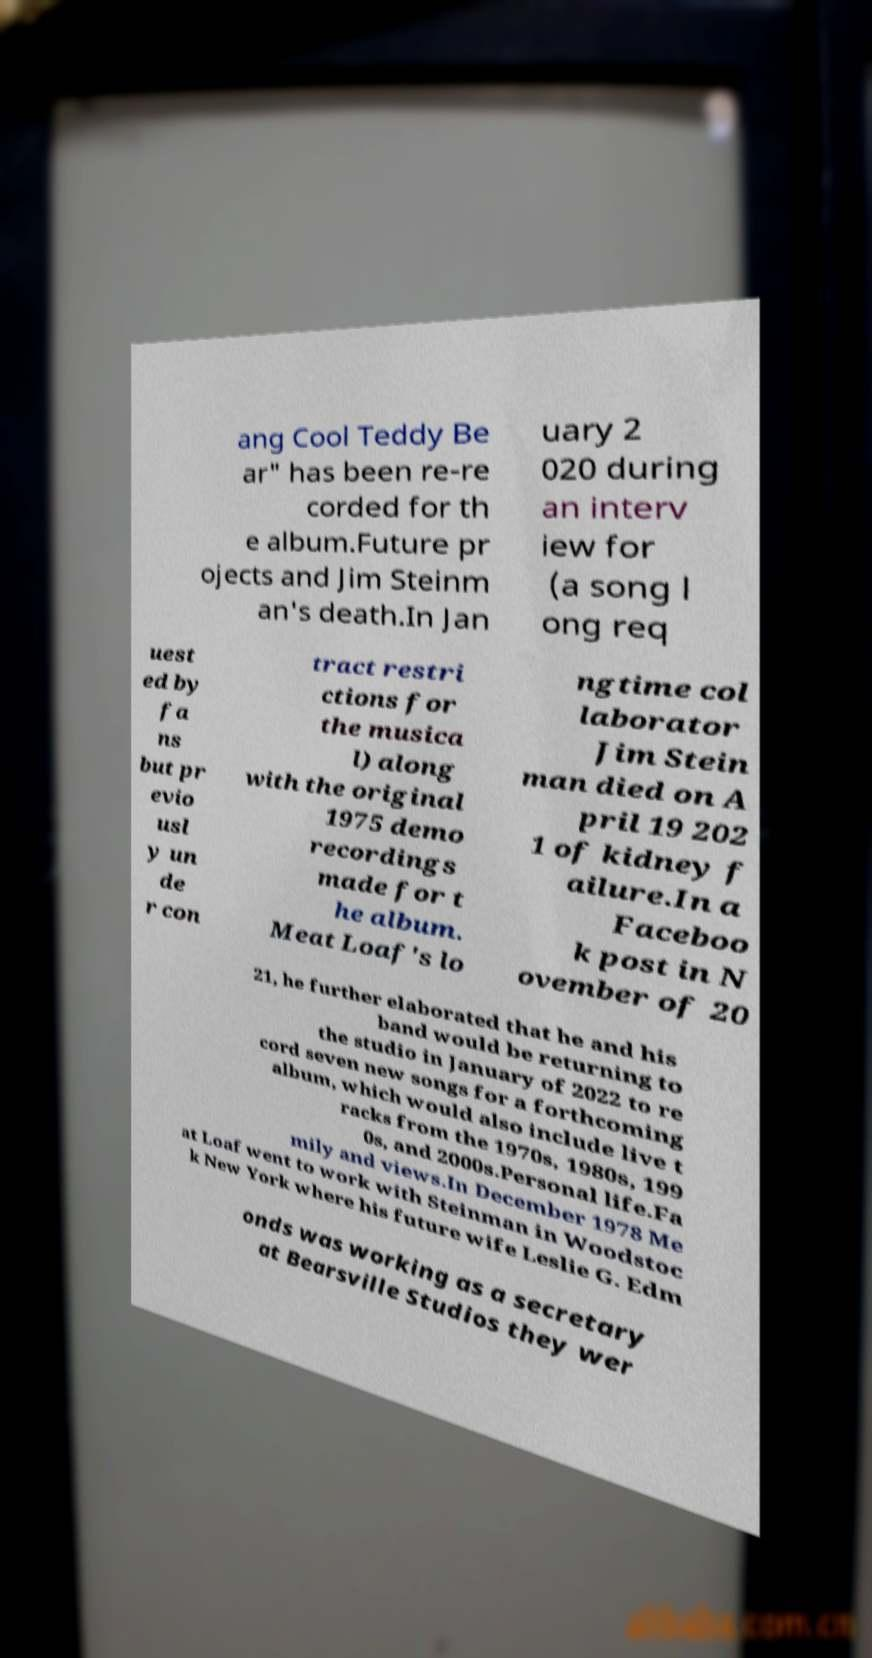Could you extract and type out the text from this image? ang Cool Teddy Be ar" has been re-re corded for th e album.Future pr ojects and Jim Steinm an's death.In Jan uary 2 020 during an interv iew for (a song l ong req uest ed by fa ns but pr evio usl y un de r con tract restri ctions for the musica l) along with the original 1975 demo recordings made for t he album. Meat Loaf's lo ngtime col laborator Jim Stein man died on A pril 19 202 1 of kidney f ailure.In a Faceboo k post in N ovember of 20 21, he further elaborated that he and his band would be returning to the studio in January of 2022 to re cord seven new songs for a forthcoming album, which would also include live t racks from the 1970s, 1980s, 199 0s, and 2000s.Personal life.Fa mily and views.In December 1978 Me at Loaf went to work with Steinman in Woodstoc k New York where his future wife Leslie G. Edm onds was working as a secretary at Bearsville Studios they wer 